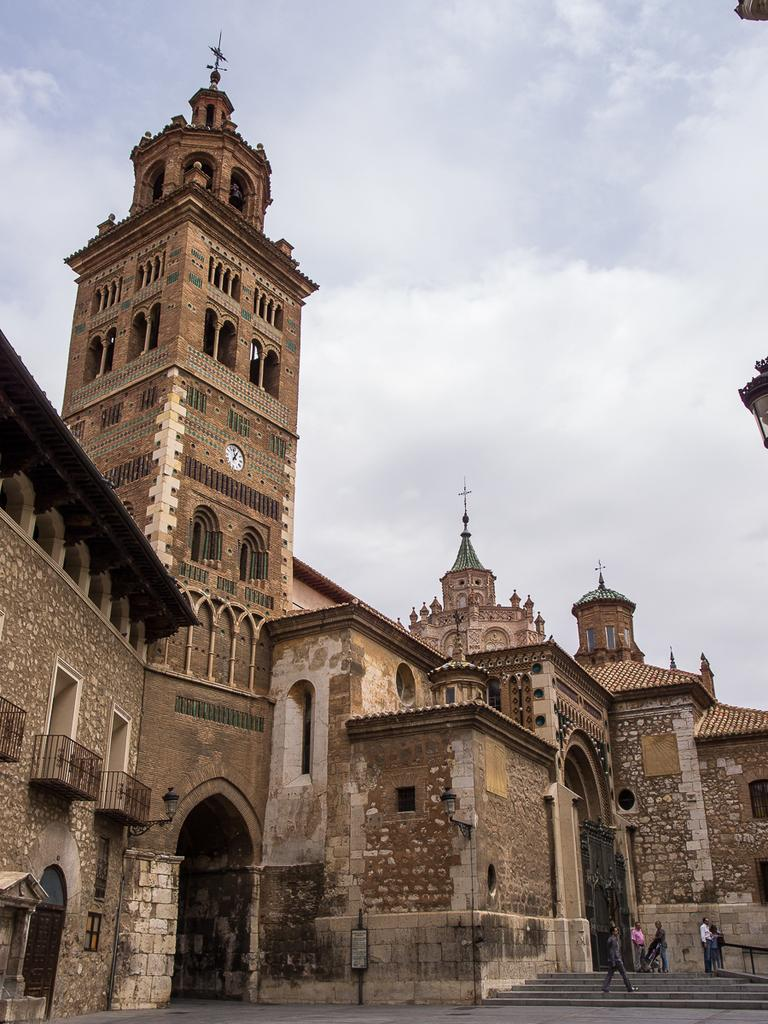What type of structure is in the image? There is a building in the image. What architectural features can be seen on the building? The building has arches, pillars, windows, and balconies. What is present at the bottom of the building? There are steps in the image. Are there any people in the image? Yes, there are people in the image. What is visible in the background of the image? The sky is visible in the background of the image, and there are clouds in the sky. What type of berry is being used as a decoration on the building's balcony? There are no berries present on the building's balcony in the image. How many tails can be seen on the people in the image? There are no tails visible on the people in the image. 